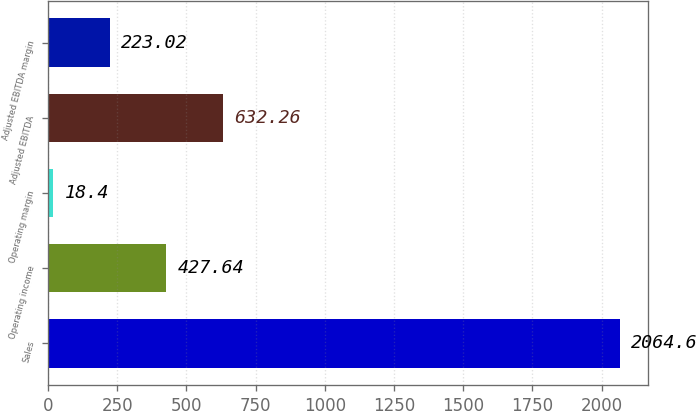Convert chart. <chart><loc_0><loc_0><loc_500><loc_500><bar_chart><fcel>Sales<fcel>Operating income<fcel>Operating margin<fcel>Adjusted EBITDA<fcel>Adjusted EBITDA margin<nl><fcel>2064.6<fcel>427.64<fcel>18.4<fcel>632.26<fcel>223.02<nl></chart> 